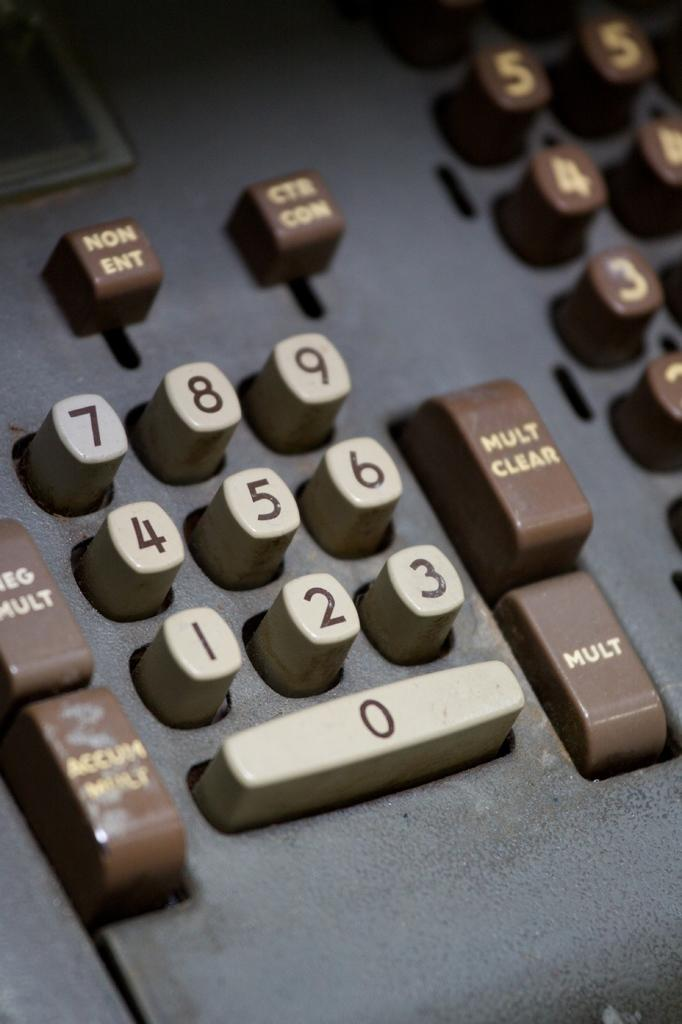Provide a one-sentence caption for the provided image. An old adding machine with special buttons for Mult Clear, Mult and others. 